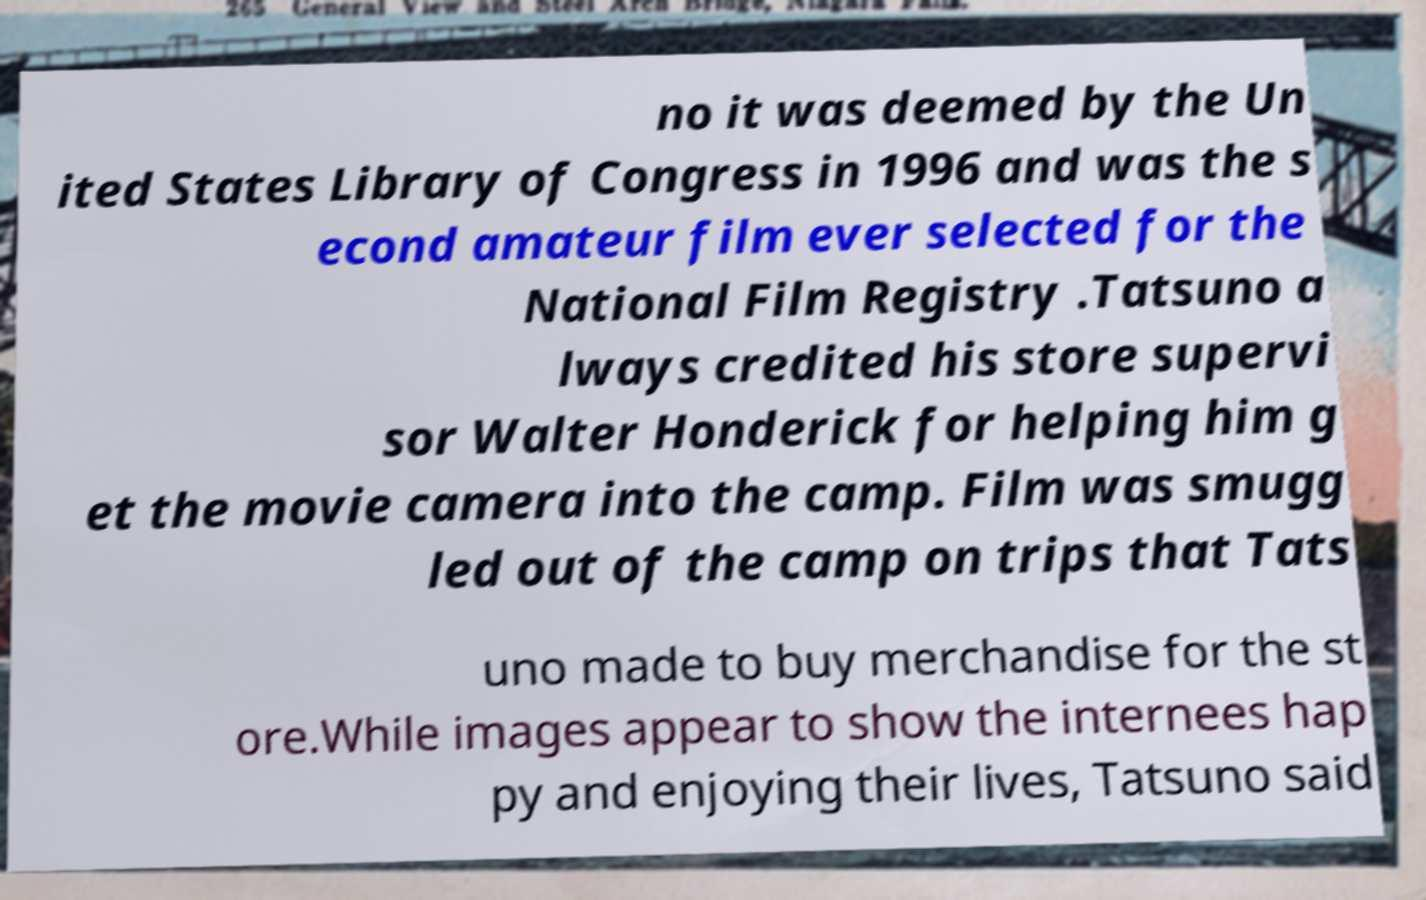There's text embedded in this image that I need extracted. Can you transcribe it verbatim? no it was deemed by the Un ited States Library of Congress in 1996 and was the s econd amateur film ever selected for the National Film Registry .Tatsuno a lways credited his store supervi sor Walter Honderick for helping him g et the movie camera into the camp. Film was smugg led out of the camp on trips that Tats uno made to buy merchandise for the st ore.While images appear to show the internees hap py and enjoying their lives, Tatsuno said 